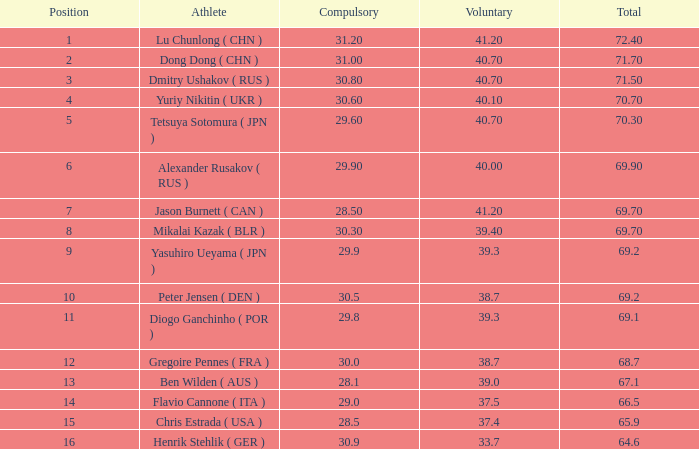5m, an obligatory figure of 3 None. 